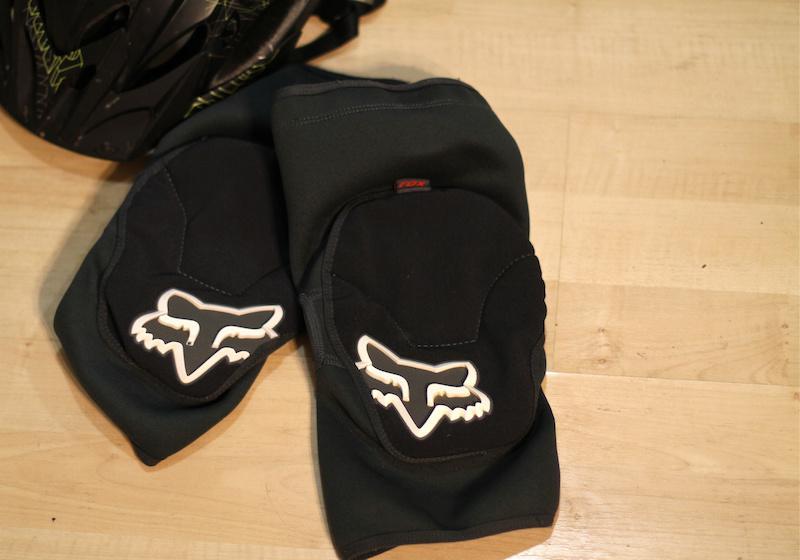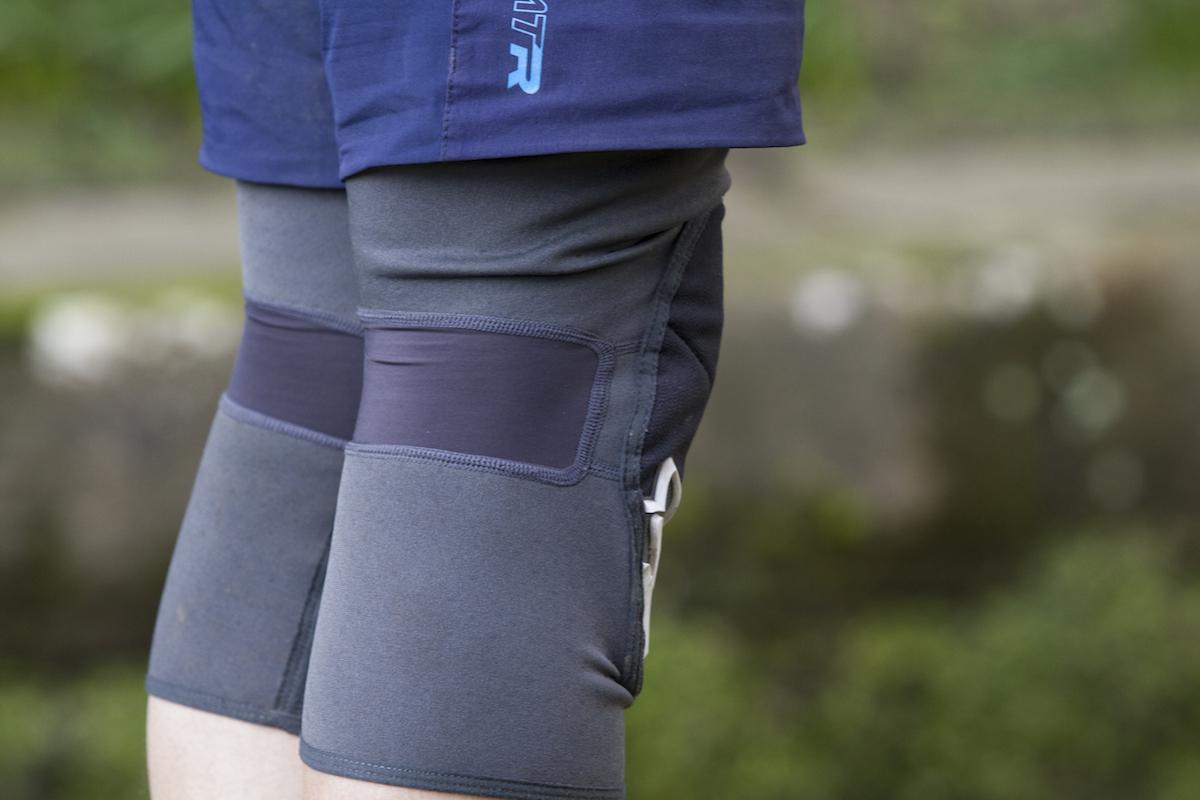The first image is the image on the left, the second image is the image on the right. For the images displayed, is the sentence "At least one knee pad is not worn by a human." factually correct? Answer yes or no. Yes. 